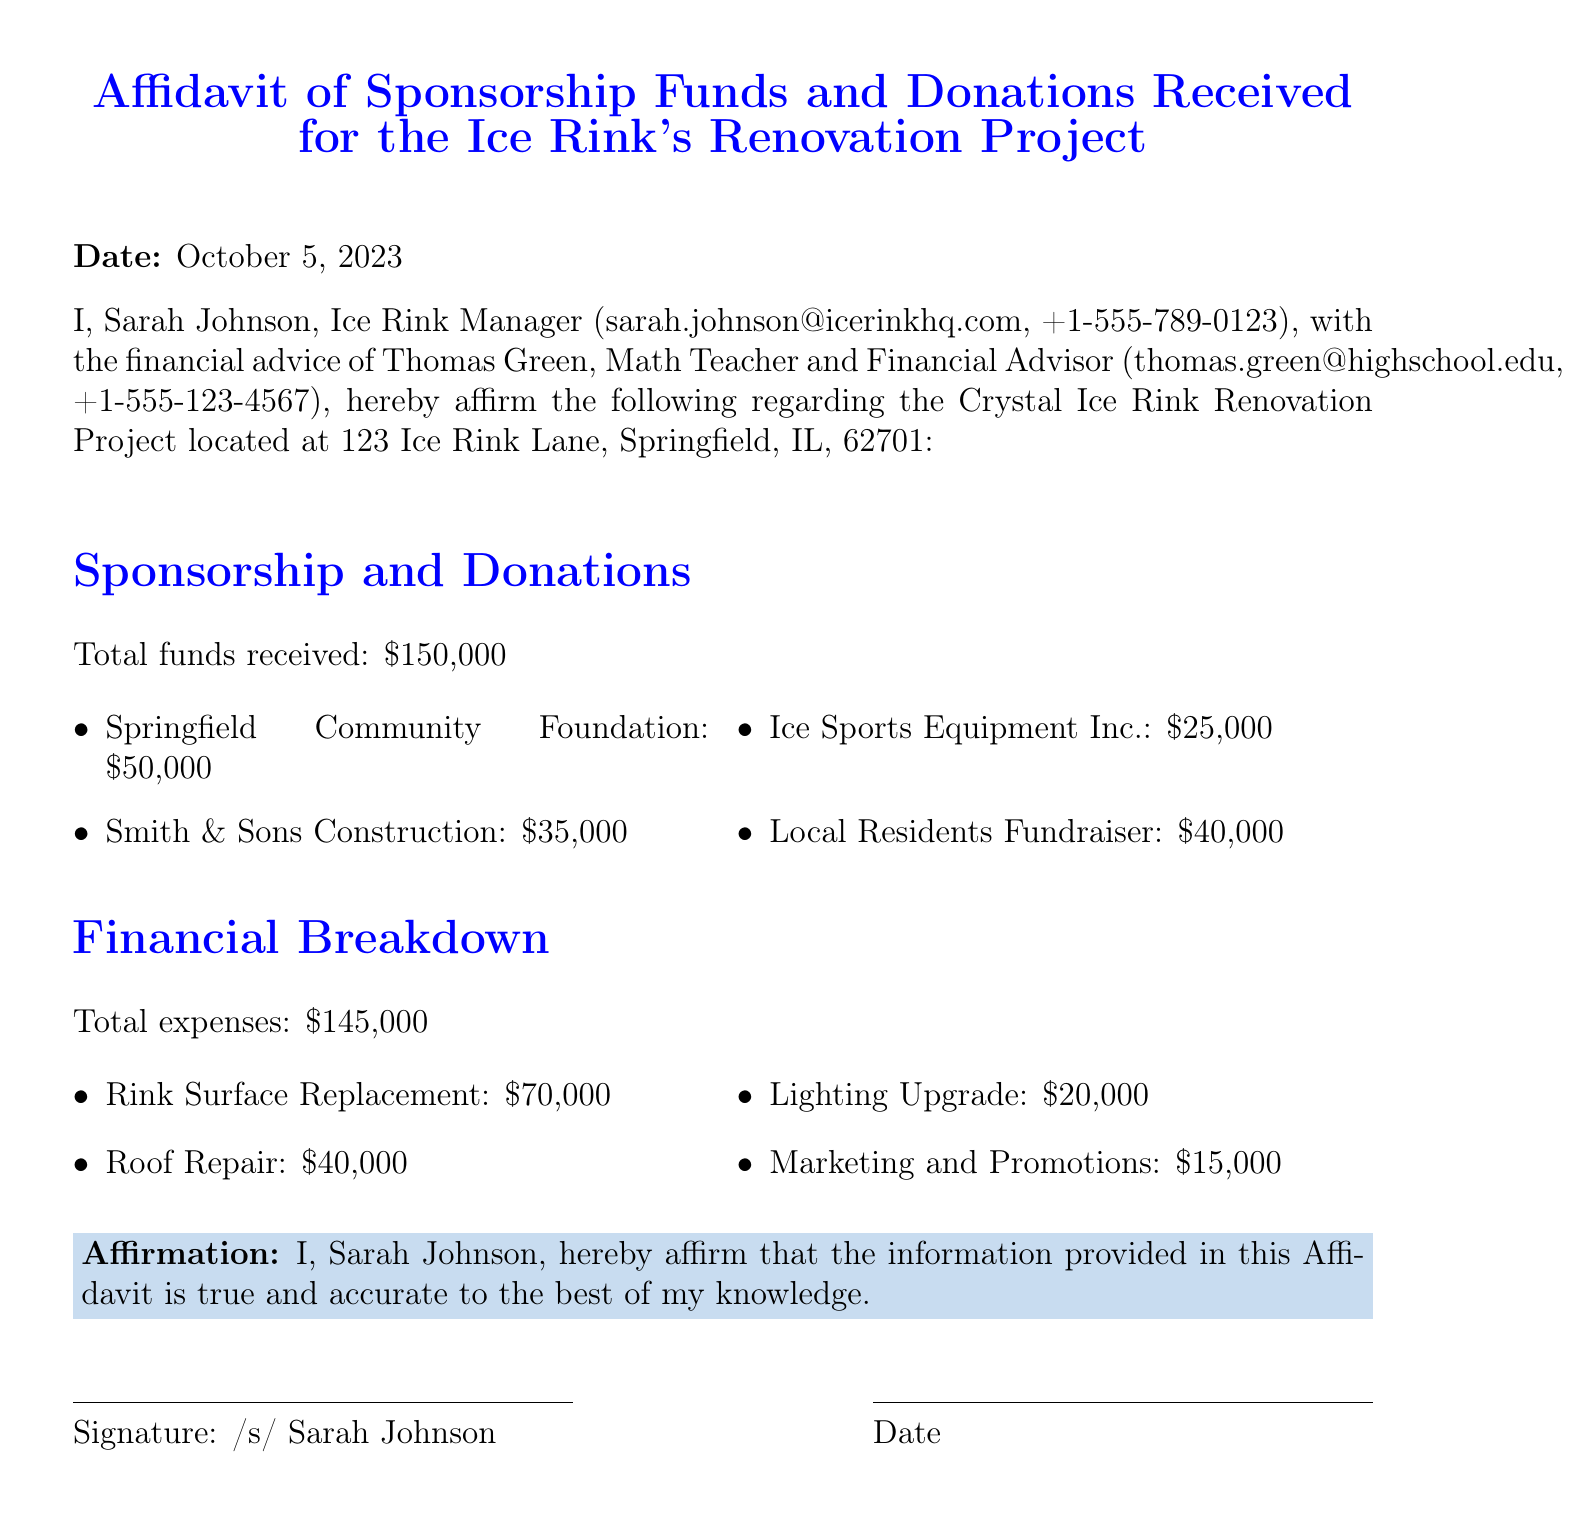What is the total funds received? The total funds received from various sources is explicitly stated in the document.
Answer: $150,000 Who is the Ice Rink Manager? The document identifies the Ice Rink Manager and provides contact details.
Answer: Sarah Johnson What is the contribution of Springfield Community Foundation? The document lists the individual contributions from each sponsor, including this one.
Answer: $50,000 What is the cost for Rink Surface Replacement? The financial breakdown specifies the expenses related to this specific project.
Answer: $70,000 How much was spent on Marketing and Promotions? This expense is clearly listed in the financial breakdown section of the document.
Answer: $15,000 What is the date of the affidavit? The document includes the date at the beginning as part of the official statement.
Answer: October 5, 2023 How much did Local Residents Fundraiser contribute? The document mentions the total contribution from local residents in the sponsorship section.
Answer: $40,000 What is the total expenses amount? The total expenses are explicitly stated in the financial breakdown section.
Answer: $145,000 What is the financial advisor's name? The document provides the name of the financial advisor involved in the project.
Answer: Thomas Green 